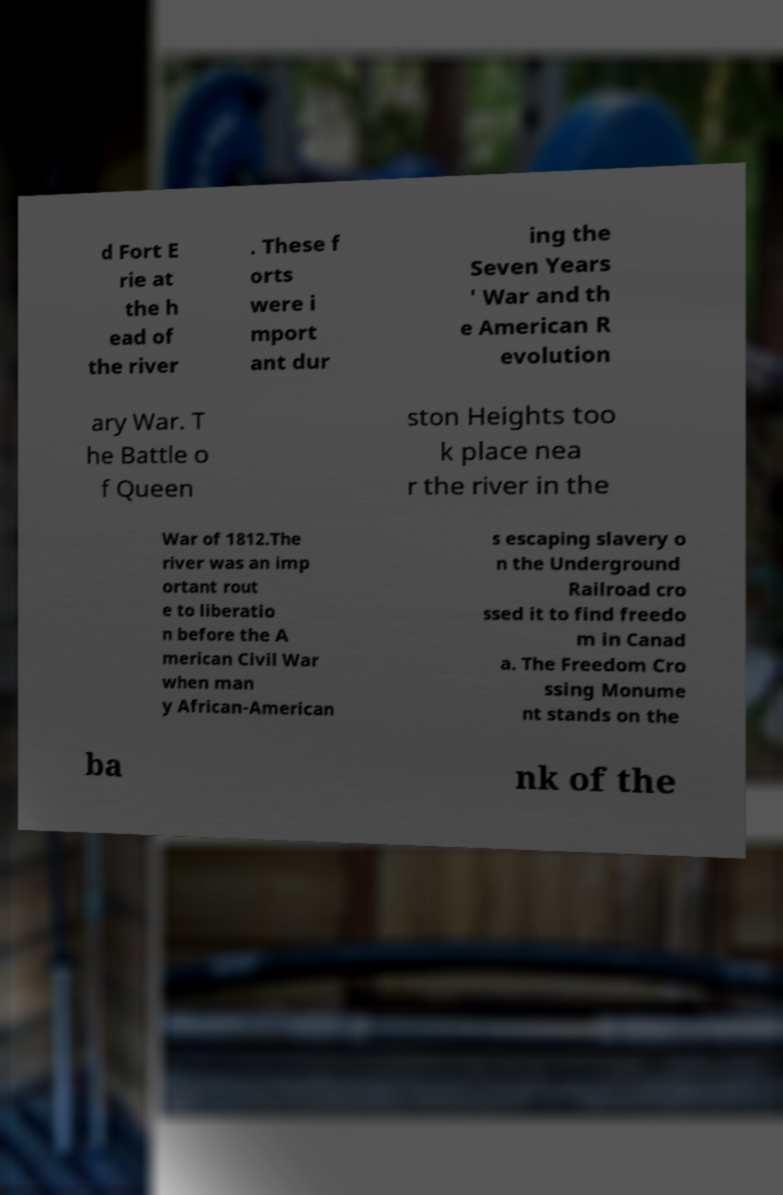Can you accurately transcribe the text from the provided image for me? d Fort E rie at the h ead of the river . These f orts were i mport ant dur ing the Seven Years ' War and th e American R evolution ary War. T he Battle o f Queen ston Heights too k place nea r the river in the War of 1812.The river was an imp ortant rout e to liberatio n before the A merican Civil War when man y African-American s escaping slavery o n the Underground Railroad cro ssed it to find freedo m in Canad a. The Freedom Cro ssing Monume nt stands on the ba nk of the 